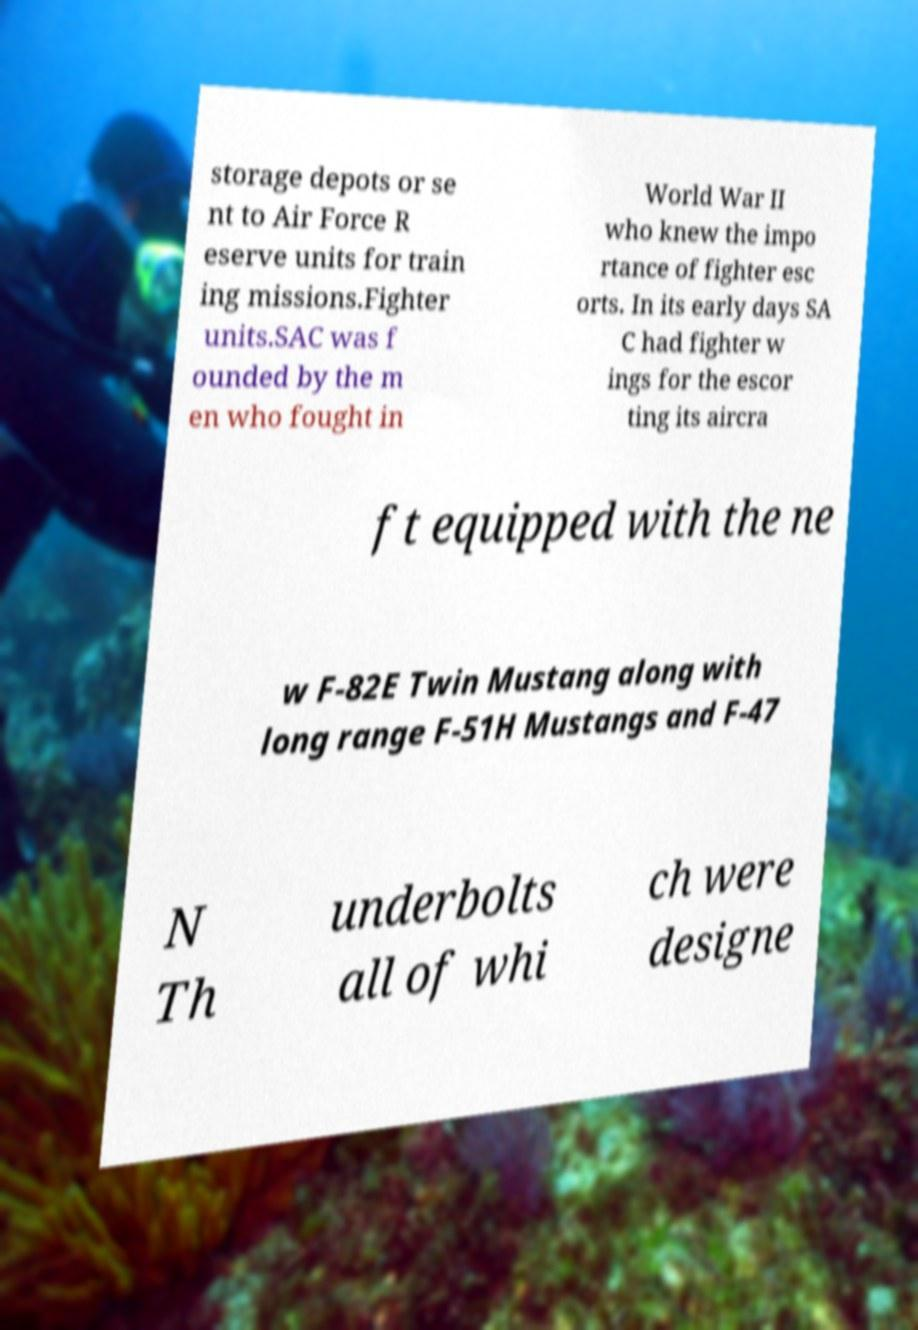Please read and relay the text visible in this image. What does it say? storage depots or se nt to Air Force R eserve units for train ing missions.Fighter units.SAC was f ounded by the m en who fought in World War II who knew the impo rtance of fighter esc orts. In its early days SA C had fighter w ings for the escor ting its aircra ft equipped with the ne w F-82E Twin Mustang along with long range F-51H Mustangs and F-47 N Th underbolts all of whi ch were designe 